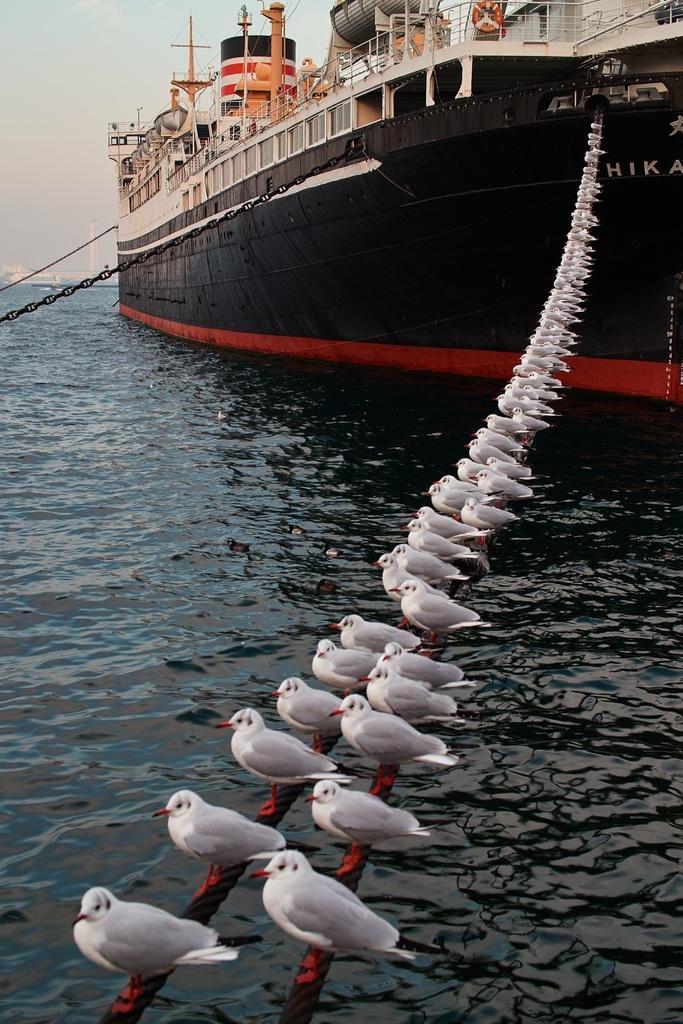Describe this image in one or two sentences. In this image, we can see a ship sailing on the water. We can see a few birds on some objects. We can also see the sky. 